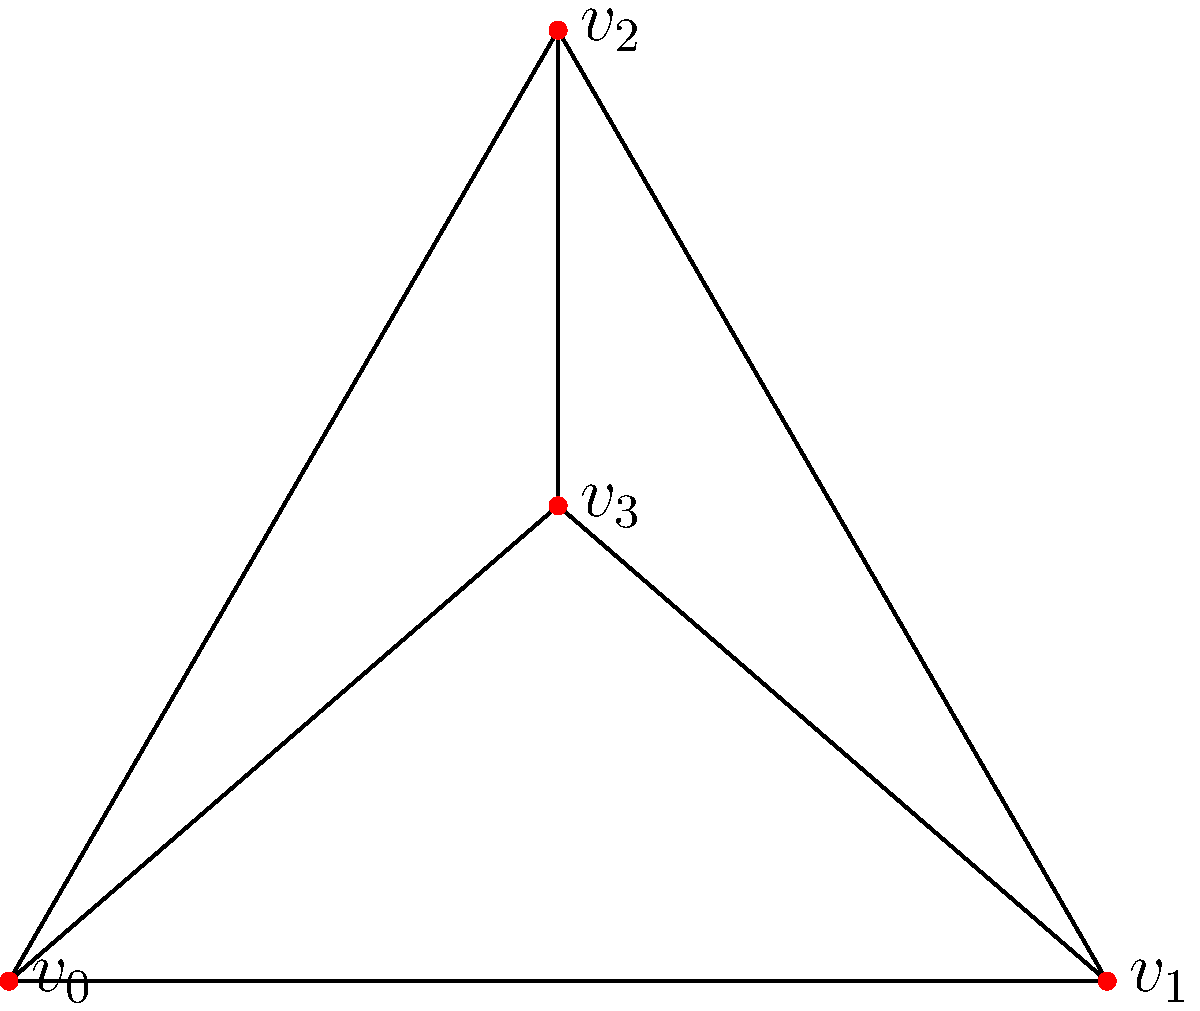Consider the simplicial complex $K$ representing a narrative structure, as shown in the figure. Calculate the first homology group $H_1(K)$ and interpret its meaning in the context of storytelling. To calculate the first homology group $H_1(K)$ and interpret its meaning for storytelling, we'll follow these steps:

1) First, identify the simplices:
   0-simplices: $\{v_0, v_1, v_2, v_3\}$
   1-simplices: $\{[v_0v_1], [v_0v_2], [v_1v_2], [v_0v_3], [v_1v_3], [v_2v_3]\}$
   2-simplices: $\{[v_0v_1v_2], [v_0v_2v_3]\}$

2) Calculate the chain groups:
   $C_0 = \mathbb{Z}^4$, $C_1 = \mathbb{Z}^6$, $C_2 = \mathbb{Z}^2$

3) Determine the boundary maps:
   $\partial_2: C_2 \to C_1$ and $\partial_1: C_1 \to C_0$

4) Calculate the kernel of $\partial_1$ (cycles):
   $\ker(\partial_1) = \mathbb{Z}$ (generated by the cycle $[v_0v_1] + [v_1v_3] - [v_0v_3]$)

5) Calculate the image of $\partial_2$ (boundaries):
   $\text{im}(\partial_2) = 0$ (all 2-simplices form a boundary)

6) The first homology group is:
   $H_1(K) = \ker(\partial_1) / \text{im}(\partial_2) = \mathbb{Z}$

Interpretation for storytelling:
The non-zero first homology group $H_1(K) = \mathbb{Z}$ indicates the presence of one independent cycle or "loop" in the narrative structure. This can be interpreted as a circular or recursive element in the story, such as:
- A time loop where events repeat
- A character's journey that ends where it began
- A recurring theme or motif that connects different parts of the narrative

The fact that there's only one generator for $H_1(K)$ suggests a single main cyclic element in the story structure, providing coherence and depth to the narrative without overcomplexity.
Answer: $H_1(K) = \mathbb{Z}$, representing one cyclic narrative element 